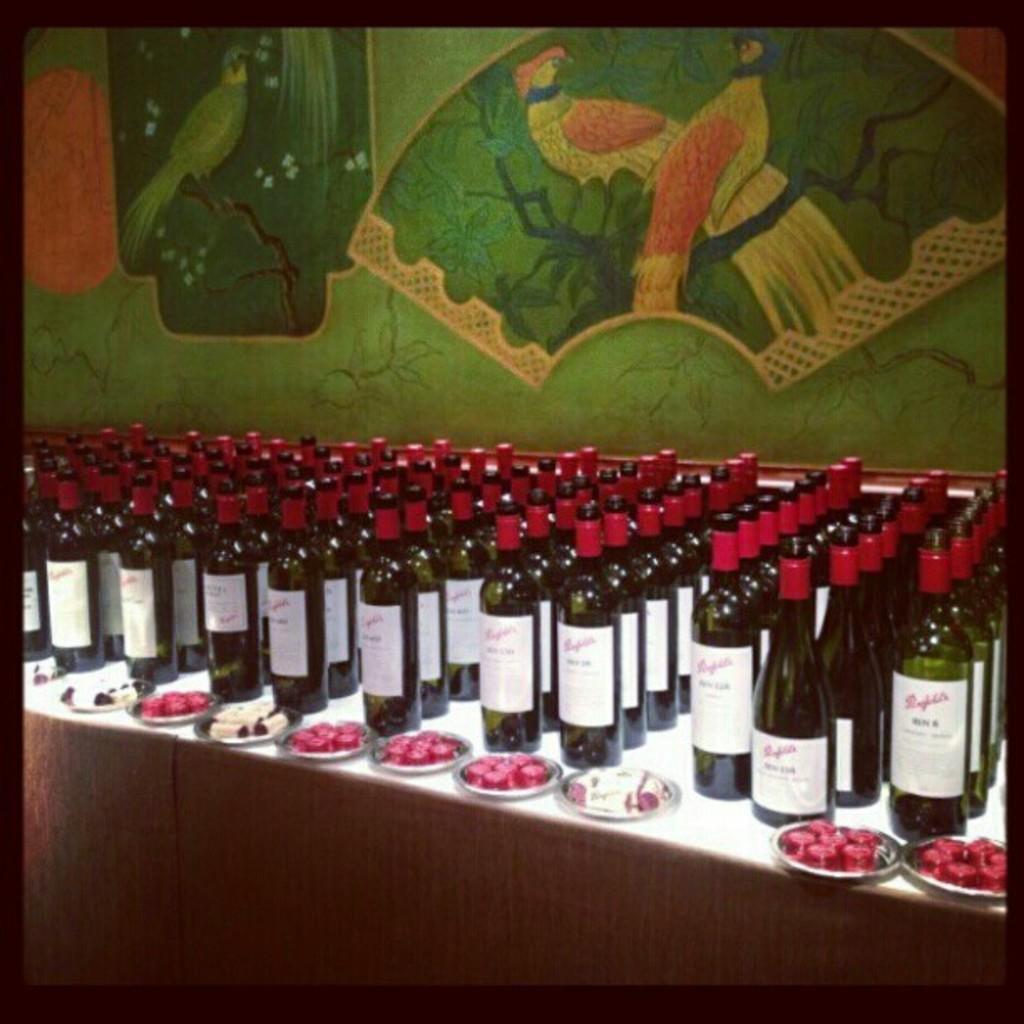Please provide a concise description of this image. In this image I can see many wine bottles on the table. There is a plate on the table. The bottles caps is in red color. At the back side there is green wall. 